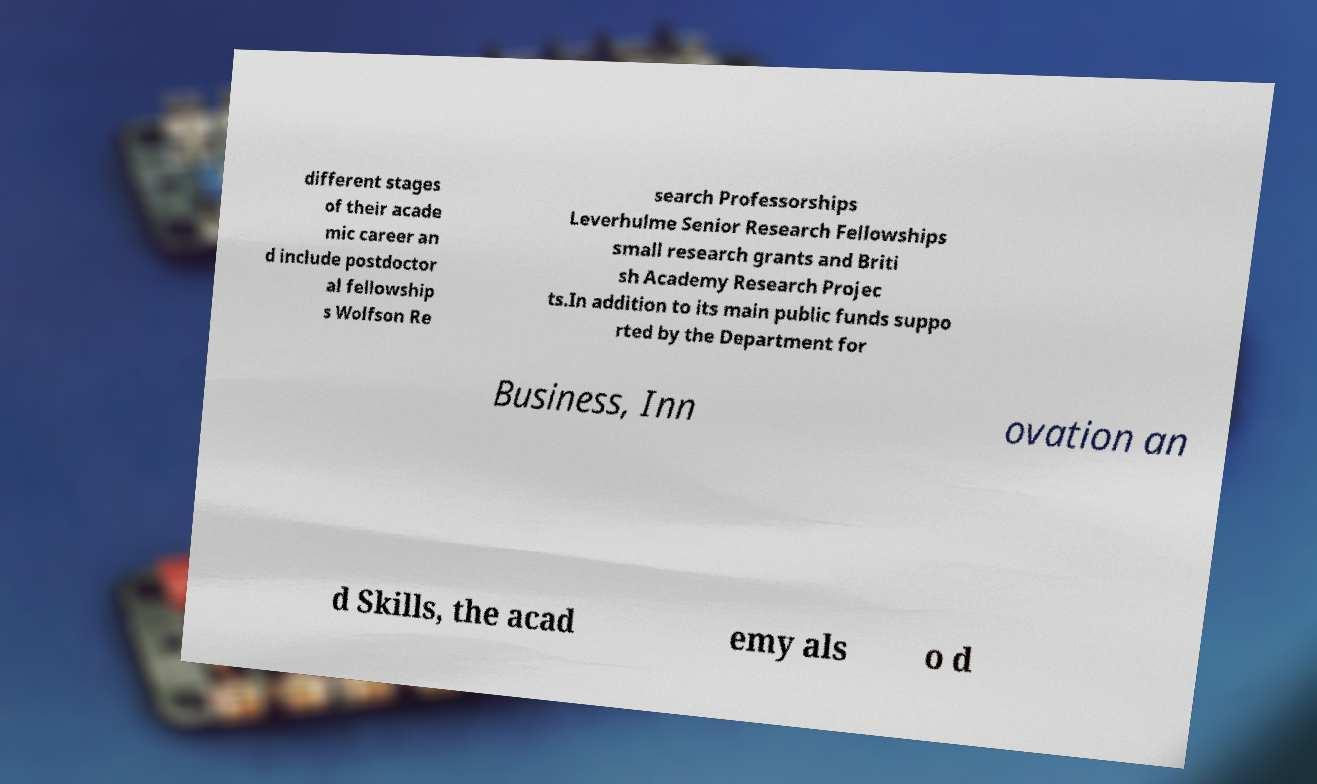Please read and relay the text visible in this image. What does it say? different stages of their acade mic career an d include postdoctor al fellowship s Wolfson Re search Professorships Leverhulme Senior Research Fellowships small research grants and Briti sh Academy Research Projec ts.In addition to its main public funds suppo rted by the Department for Business, Inn ovation an d Skills, the acad emy als o d 